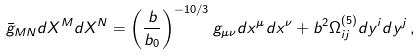<formula> <loc_0><loc_0><loc_500><loc_500>\bar { g } _ { M N } d X ^ { M } d X ^ { N } = \left ( \frac { b } { b _ { 0 } } \right ) ^ { - 1 0 / 3 } g _ { \mu \nu } d x ^ { \mu } d x ^ { \nu } + b ^ { 2 } \Omega _ { i j } ^ { ( 5 ) } d y ^ { i } d y ^ { j } \, ,</formula> 